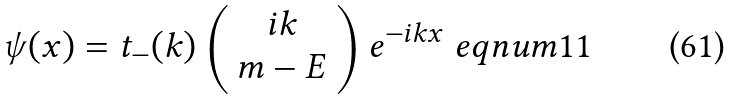Convert formula to latex. <formula><loc_0><loc_0><loc_500><loc_500>\psi ( x ) = t _ { - } ( k ) \left ( \begin{array} { c } i k \\ m - E \end{array} \right ) e ^ { - i k x } \ e q n u m { 1 1 }</formula> 